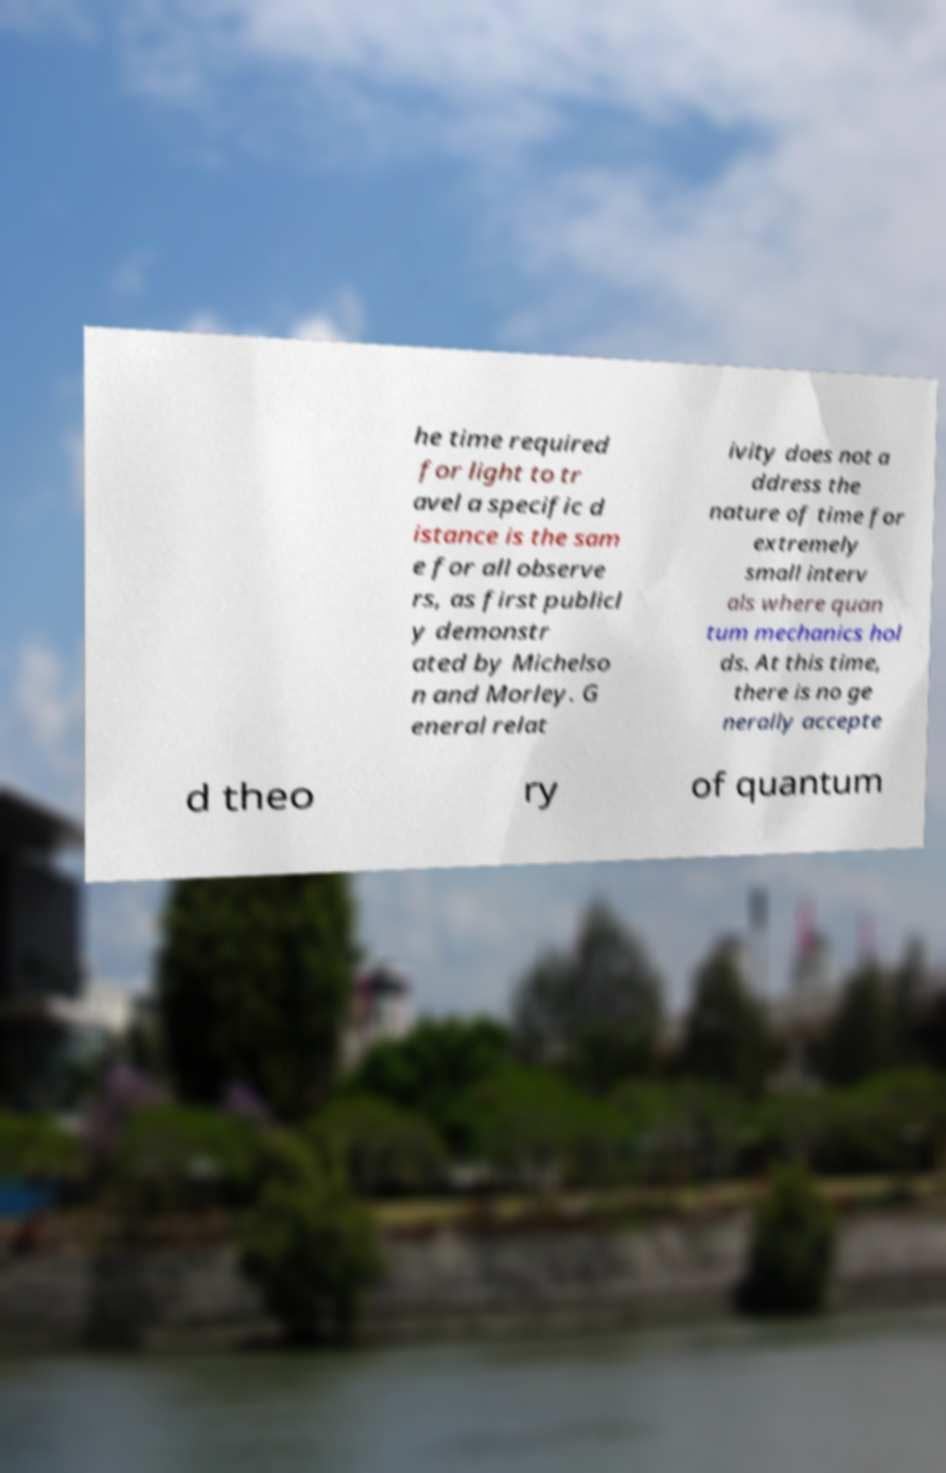What messages or text are displayed in this image? I need them in a readable, typed format. he time required for light to tr avel a specific d istance is the sam e for all observe rs, as first publicl y demonstr ated by Michelso n and Morley. G eneral relat ivity does not a ddress the nature of time for extremely small interv als where quan tum mechanics hol ds. At this time, there is no ge nerally accepte d theo ry of quantum 